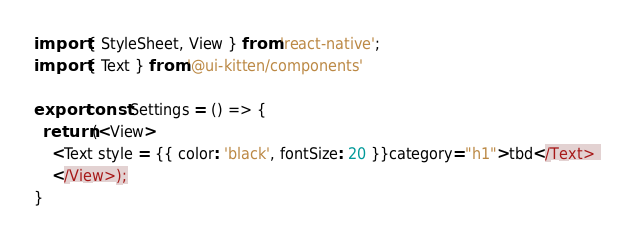Convert code to text. <code><loc_0><loc_0><loc_500><loc_500><_JavaScript_>import { StyleSheet, View } from 'react-native';
import { Text } from '@ui-kitten/components'

export const Settings = () => {
  return (<View> 
    <Text style = {{ color: 'black', fontSize: 20 }}category="h1">tbd</Text> 
    </View>);
}</code> 